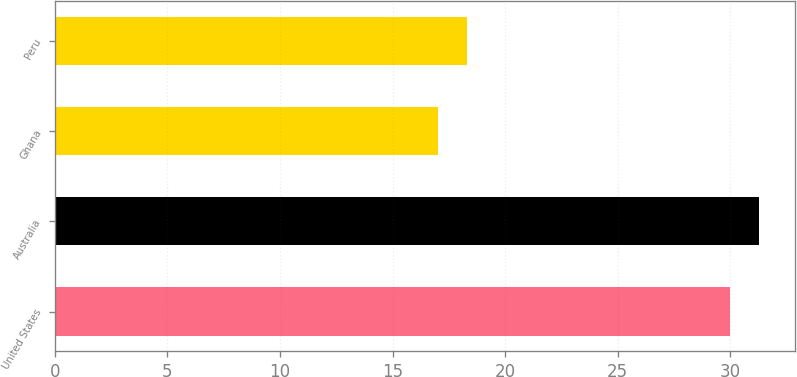Convert chart. <chart><loc_0><loc_0><loc_500><loc_500><bar_chart><fcel>United States<fcel>Australia<fcel>Ghana<fcel>Peru<nl><fcel>30<fcel>31.3<fcel>17<fcel>18.3<nl></chart> 